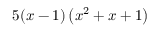<formula> <loc_0><loc_0><loc_500><loc_500>5 ( x - 1 ) \left ( x ^ { 2 } + x + 1 \right )</formula> 